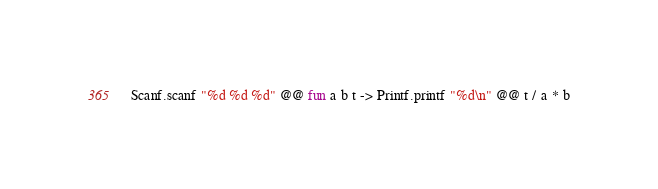<code> <loc_0><loc_0><loc_500><loc_500><_OCaml_>Scanf.scanf "%d %d %d" @@ fun a b t -> Printf.printf "%d\n" @@ t / a * b</code> 